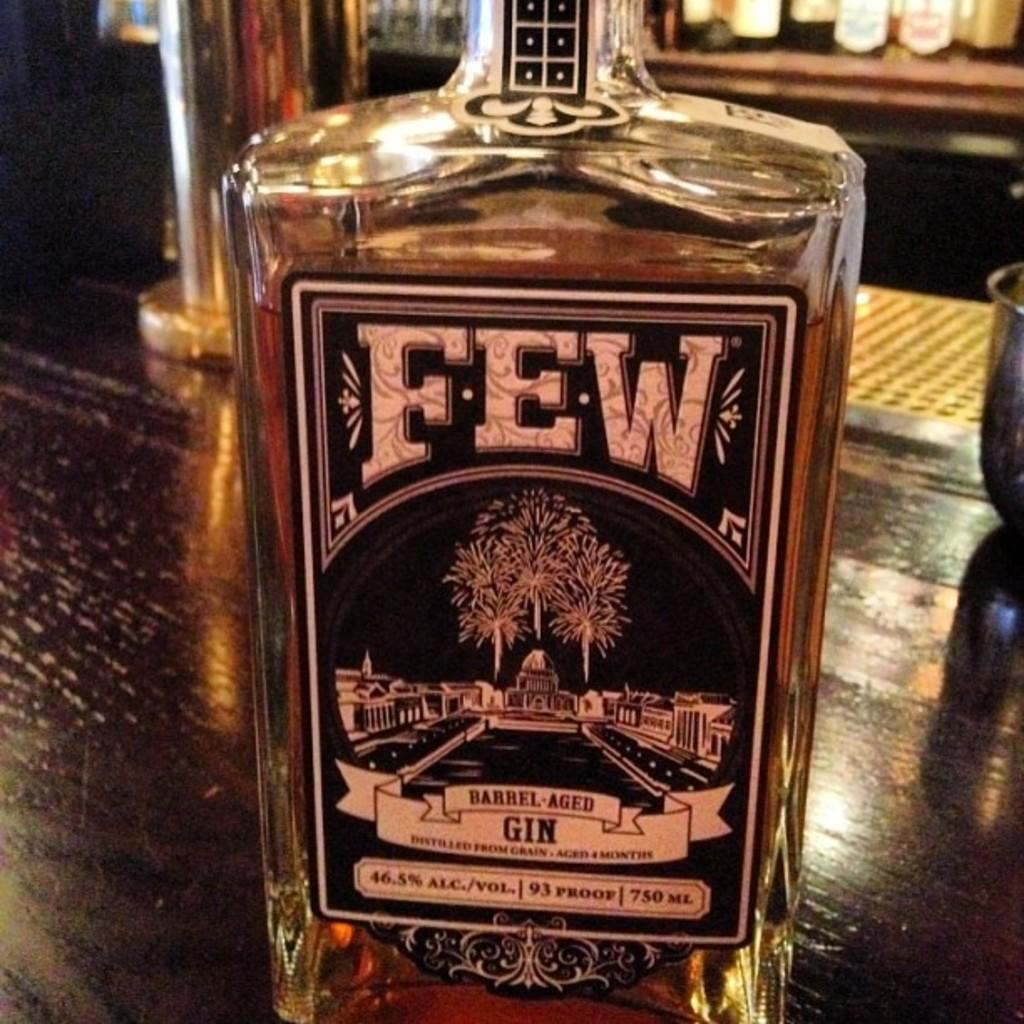<image>
Give a short and clear explanation of the subsequent image. A clear bottle of FEW barrel aged Gin 